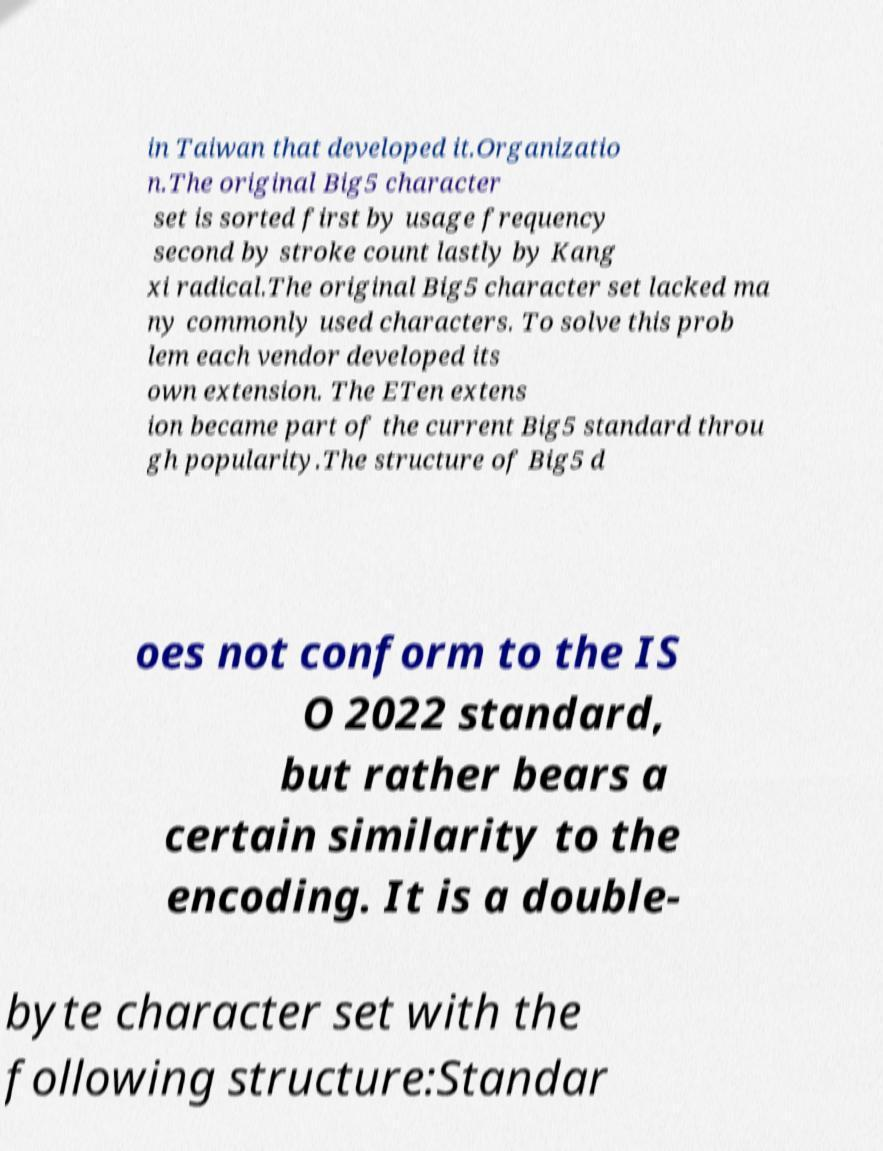There's text embedded in this image that I need extracted. Can you transcribe it verbatim? in Taiwan that developed it.Organizatio n.The original Big5 character set is sorted first by usage frequency second by stroke count lastly by Kang xi radical.The original Big5 character set lacked ma ny commonly used characters. To solve this prob lem each vendor developed its own extension. The ETen extens ion became part of the current Big5 standard throu gh popularity.The structure of Big5 d oes not conform to the IS O 2022 standard, but rather bears a certain similarity to the encoding. It is a double- byte character set with the following structure:Standar 